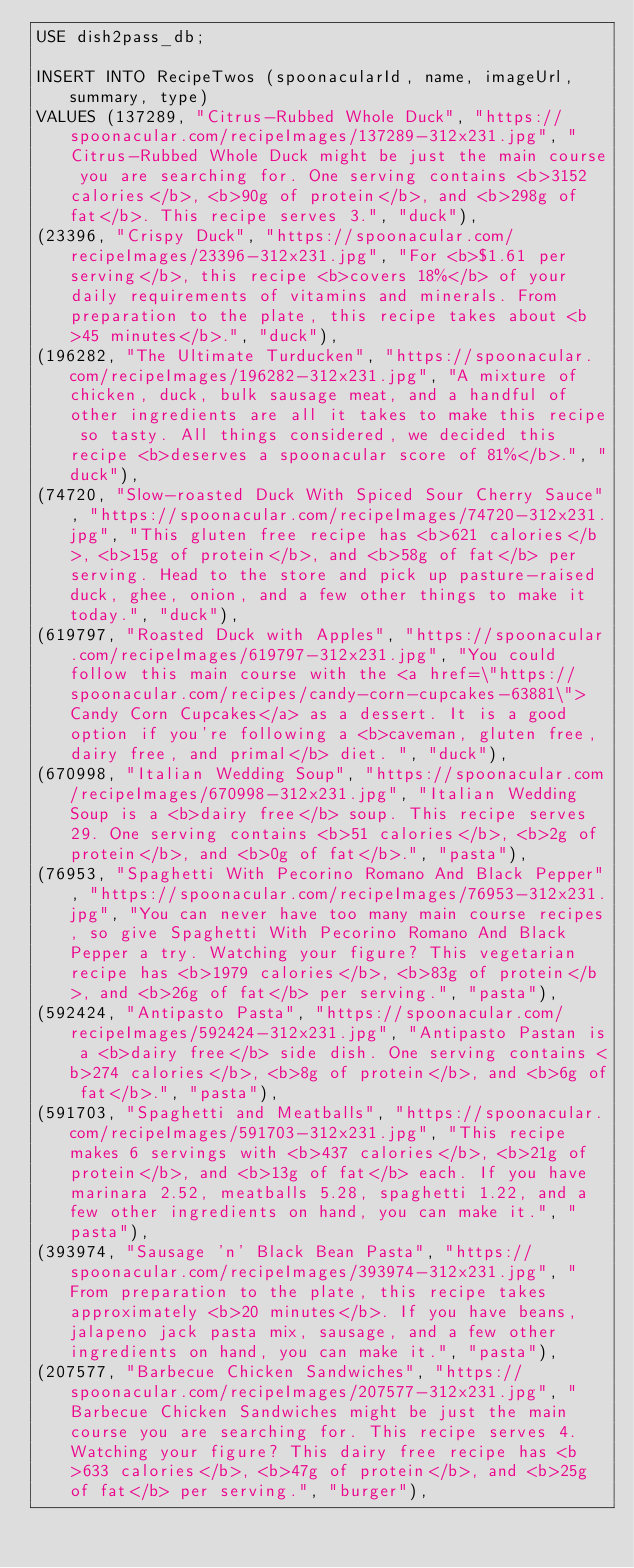<code> <loc_0><loc_0><loc_500><loc_500><_SQL_>USE dish2pass_db;

INSERT INTO RecipeTwos (spoonacularId, name, imageUrl, summary, type)
VALUES (137289, "Citrus-Rubbed Whole Duck", "https://spoonacular.com/recipeImages/137289-312x231.jpg", "Citrus-Rubbed Whole Duck might be just the main course you are searching for. One serving contains <b>3152 calories</b>, <b>90g of protein</b>, and <b>298g of fat</b>. This recipe serves 3.", "duck"), 
(23396, "Crispy Duck", "https://spoonacular.com/recipeImages/23396-312x231.jpg", "For <b>$1.61 per serving</b>, this recipe <b>covers 18%</b> of your daily requirements of vitamins and minerals. From preparation to the plate, this recipe takes about <b>45 minutes</b>.", "duck"),
(196282, "The Ultimate Turducken", "https://spoonacular.com/recipeImages/196282-312x231.jpg", "A mixture of chicken, duck, bulk sausage meat, and a handful of other ingredients are all it takes to make this recipe so tasty. All things considered, we decided this recipe <b>deserves a spoonacular score of 81%</b>.", "duck"),
(74720, "Slow-roasted Duck With Spiced Sour Cherry Sauce", "https://spoonacular.com/recipeImages/74720-312x231.jpg", "This gluten free recipe has <b>621 calories</b>, <b>15g of protein</b>, and <b>58g of fat</b> per serving. Head to the store and pick up pasture-raised duck, ghee, onion, and a few other things to make it today.", "duck"),
(619797, "Roasted Duck with Apples", "https://spoonacular.com/recipeImages/619797-312x231.jpg", "You could follow this main course with the <a href=\"https://spoonacular.com/recipes/candy-corn-cupcakes-63881\">Candy Corn Cupcakes</a> as a dessert. It is a good option if you're following a <b>caveman, gluten free, dairy free, and primal</b> diet. ", "duck"),
(670998, "Italian Wedding Soup", "https://spoonacular.com/recipeImages/670998-312x231.jpg", "Italian Wedding Soup is a <b>dairy free</b> soup. This recipe serves 29. One serving contains <b>51 calories</b>, <b>2g of protein</b>, and <b>0g of fat</b>.", "pasta"),
(76953, "Spaghetti With Pecorino Romano And Black Pepper", "https://spoonacular.com/recipeImages/76953-312x231.jpg", "You can never have too many main course recipes, so give Spaghetti With Pecorino Romano And Black Pepper a try. Watching your figure? This vegetarian recipe has <b>1979 calories</b>, <b>83g of protein</b>, and <b>26g of fat</b> per serving.", "pasta"),
(592424, "Antipasto Pasta", "https://spoonacular.com/recipeImages/592424-312x231.jpg", "Antipasto Pastan is a <b>dairy free</b> side dish. One serving contains <b>274 calories</b>, <b>8g of protein</b>, and <b>6g of fat</b>.", "pasta"),
(591703, "Spaghetti and Meatballs", "https://spoonacular.com/recipeImages/591703-312x231.jpg", "This recipe makes 6 servings with <b>437 calories</b>, <b>21g of protein</b>, and <b>13g of fat</b> each. If you have marinara 2.52, meatballs 5.28, spaghetti 1.22, and a few other ingredients on hand, you can make it.", "pasta"),
(393974, "Sausage 'n' Black Bean Pasta", "https://spoonacular.com/recipeImages/393974-312x231.jpg", "From preparation to the plate, this recipe takes approximately <b>20 minutes</b>. If you have beans, jalapeno jack pasta mix, sausage, and a few other ingredients on hand, you can make it.", "pasta"),
(207577, "Barbecue Chicken Sandwiches", "https://spoonacular.com/recipeImages/207577-312x231.jpg", "Barbecue Chicken Sandwiches might be just the main course you are searching for. This recipe serves 4. Watching your figure? This dairy free recipe has <b>633 calories</b>, <b>47g of protein</b>, and <b>25g of fat</b> per serving.", "burger"),</code> 